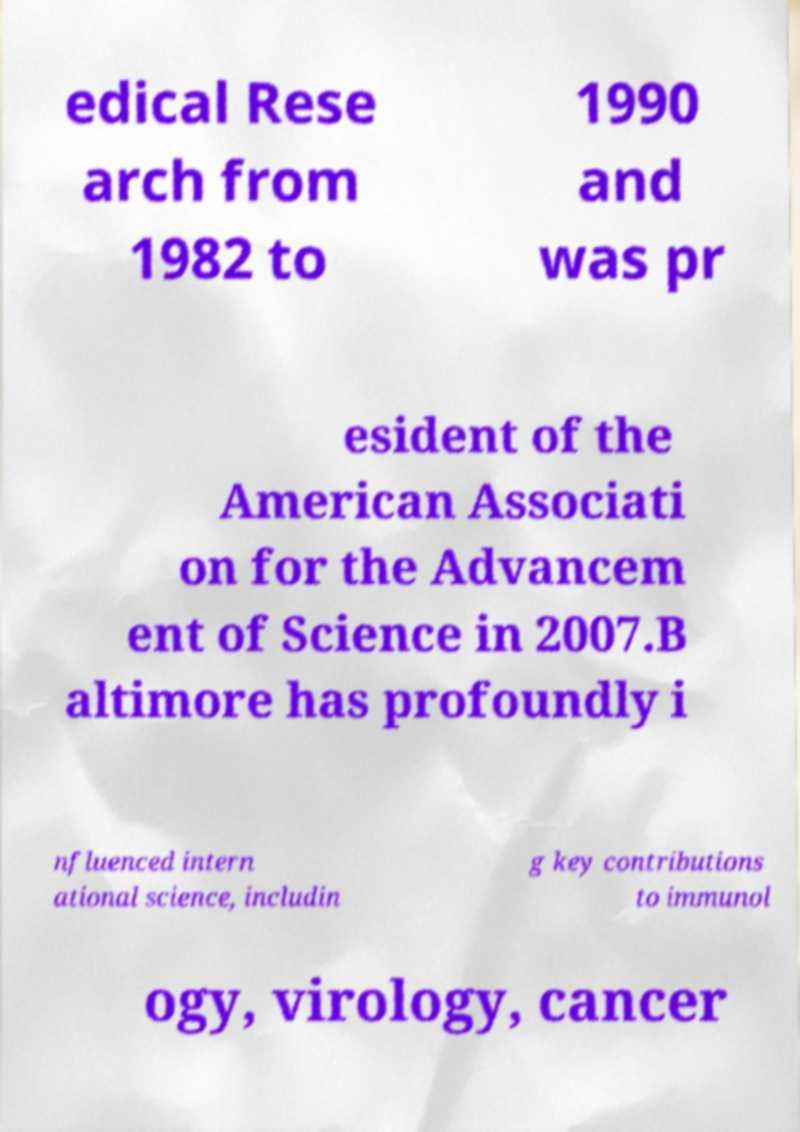Could you assist in decoding the text presented in this image and type it out clearly? edical Rese arch from 1982 to 1990 and was pr esident of the American Associati on for the Advancem ent of Science in 2007.B altimore has profoundly i nfluenced intern ational science, includin g key contributions to immunol ogy, virology, cancer 